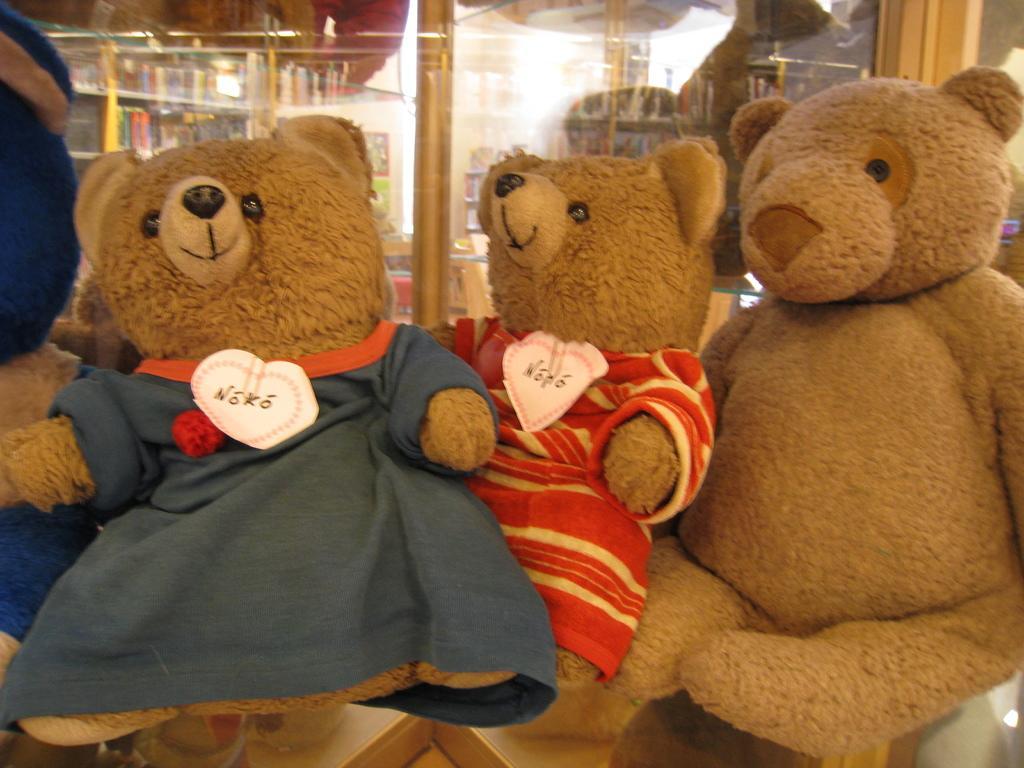In one or two sentences, can you explain what this image depicts? In this picture we can see few teddy bears, in the background we can find glass. 